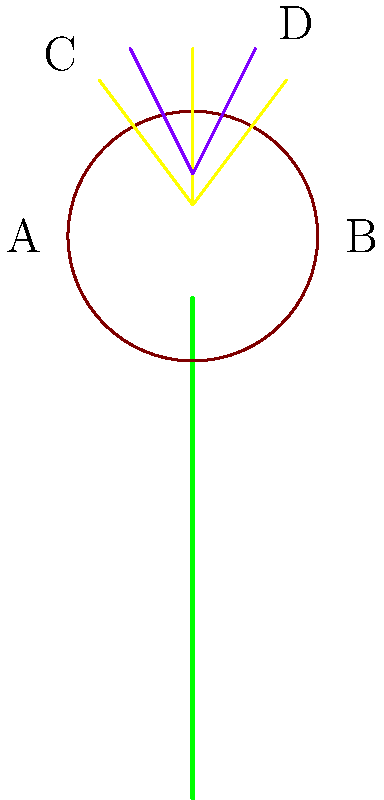In the diagram of a grass flower, identify the structures labeled A, B, C, and D. Which of these structures is responsible for pollen production? To answer this question, let's analyze each labeled structure in the grass flower diagram:

1. Structure A: This is the lemma, an outer bract that encloses the floret.
2. Structure B: This is the palea, an inner bract that, together with the lemma, encloses the reproductive parts of the grass flower.
3. Structure C: These are the stamens, the male reproductive structures of the flower.
4. Structure D: These are the stigmas, the female reproductive structures that receive pollen.

Among these structures, the stamens (C) are responsible for pollen production. In grass flowers:

1. Stamens consist of filaments and anthers.
2. The anthers produce and contain pollen grains.
3. When mature, the anthers split open to release pollen.
4. The released pollen can then be carried by wind or other means to the stigmas of other grass flowers for fertilization.

Therefore, the structure responsible for pollen production is C, the stamens.
Answer: C (stamens) 